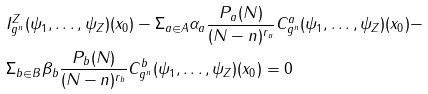<formula> <loc_0><loc_0><loc_500><loc_500>& I ^ { Z } _ { g ^ { n } } ( { \psi } _ { 1 } , \dots , { \psi } _ { Z } ) ( x _ { 0 } ) - { \Sigma } _ { a \in A } { \alpha } _ { a } \frac { P _ { a } ( N ) } { ( N - n ) ^ { r _ { a } } } C ^ { a } _ { g ^ { n } } ( { \psi } _ { 1 } , \dots , { \psi } _ { Z } ) ( x _ { 0 } ) - \\ & { \Sigma } _ { b \in B } { \beta } _ { b } \frac { P _ { b } ( N ) } { ( N - n ) ^ { r _ { b } } } C ^ { b } _ { g ^ { n } } ( { \psi } _ { 1 } , \dots , { \psi } _ { Z } ) ( x _ { 0 } ) = 0</formula> 